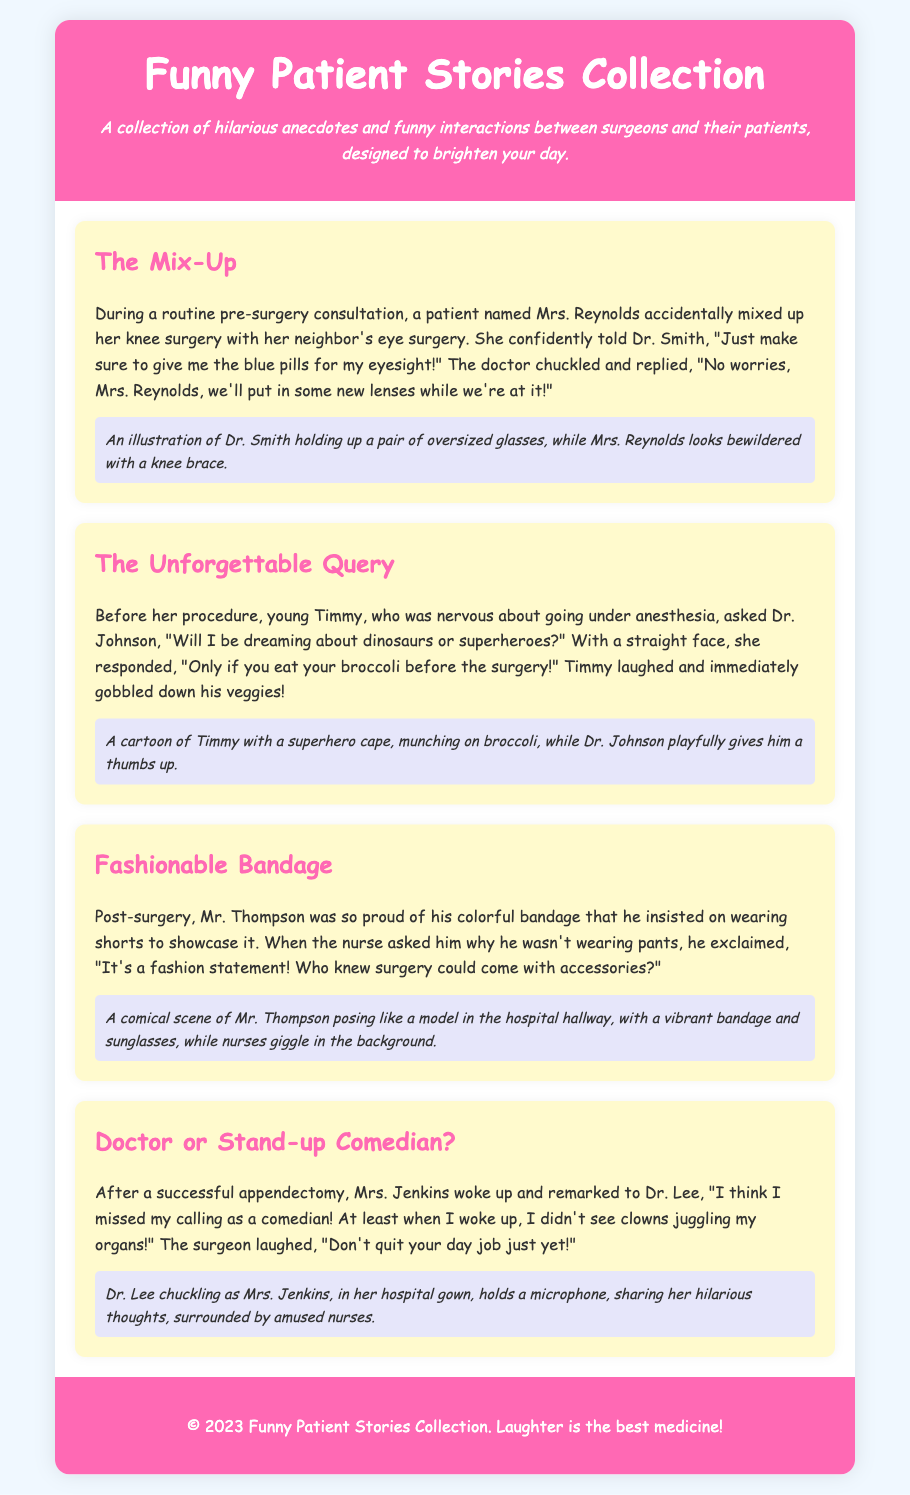What is the title of the collection? The title is presented at the top of the document as part of the header section.
Answer: Funny Patient Stories Collection How many stories are included in the collection? The document contains a total of four individual anecdotes or stories listed in the body.
Answer: Four Who is the doctor mentioned in "The Mix-Up"? The story attributes the conversation to Dr. Smith during Mrs. Reynolds' consultation.
Answer: Dr. Smith What does Timmy have to eat before his surgery? The story highlights Timmy's humorous interaction about eating vegetables before anesthesia.
Answer: Broccoli What fashion item does Mr. Thompson choose to wear post-surgery? Mr. Thompson's choice in clothing after surgery is emphasized as he wears something specific to show off his bandage.
Answer: Shorts Which character claims to have missed their calling as a comedian? The document indicates that a specific patient expresses their comedic ambitions during a conversation with the surgeon after surgery.
Answer: Mrs. Jenkins What color are the bandages Mr. Thompson is proud of? The story refers to Mr. Thompson's bandage as being colorful, emphasizing his pride.
Answer: Colorful What is the main aim of the Funny Patient Stories Collection? The description in the header clarifies the intended purpose of the collection, highlighting humor's role in interactions.
Answer: Brighten your day 